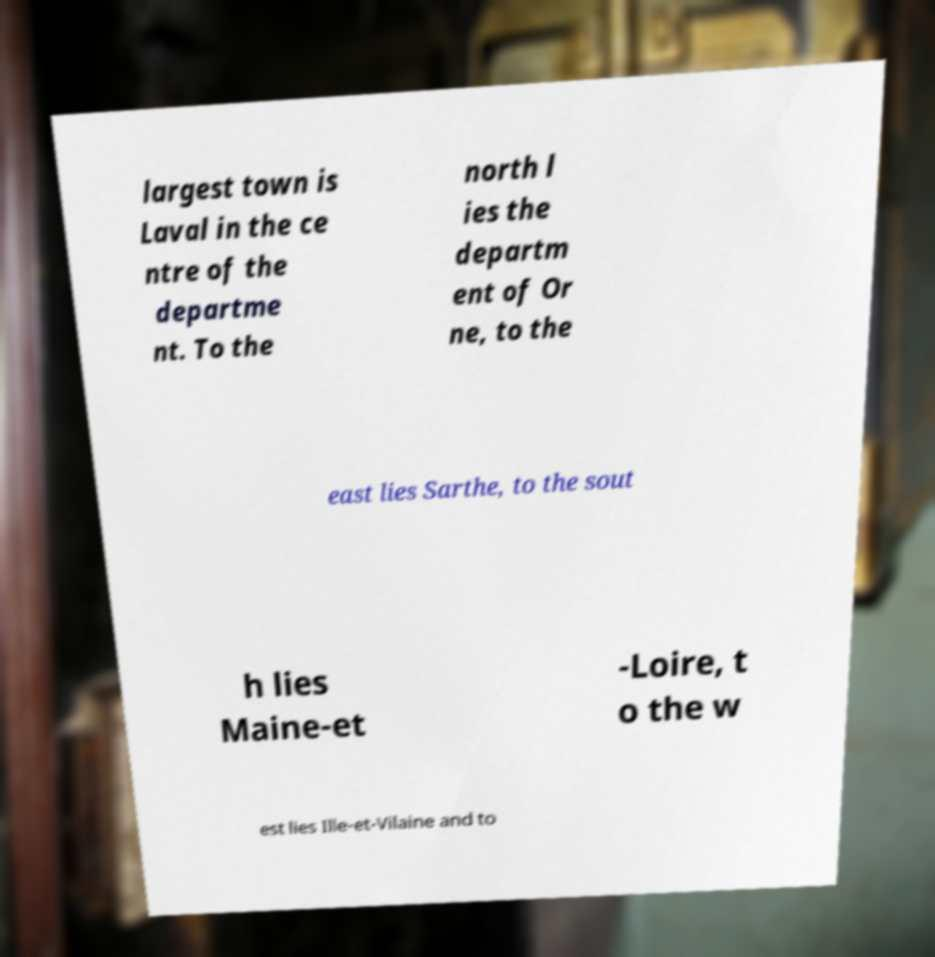For documentation purposes, I need the text within this image transcribed. Could you provide that? largest town is Laval in the ce ntre of the departme nt. To the north l ies the departm ent of Or ne, to the east lies Sarthe, to the sout h lies Maine-et -Loire, t o the w est lies Ille-et-Vilaine and to 